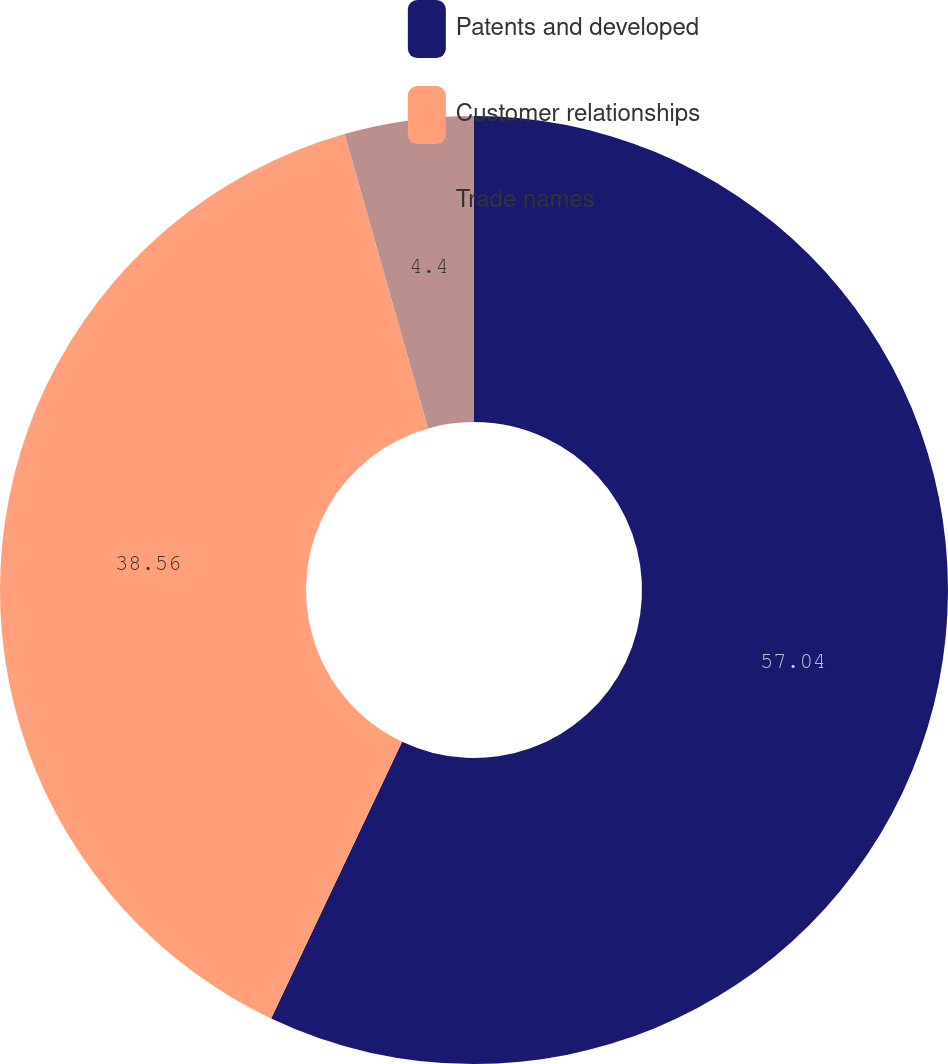<chart> <loc_0><loc_0><loc_500><loc_500><pie_chart><fcel>Patents and developed<fcel>Customer relationships<fcel>Trade names<nl><fcel>57.04%<fcel>38.56%<fcel>4.4%<nl></chart> 